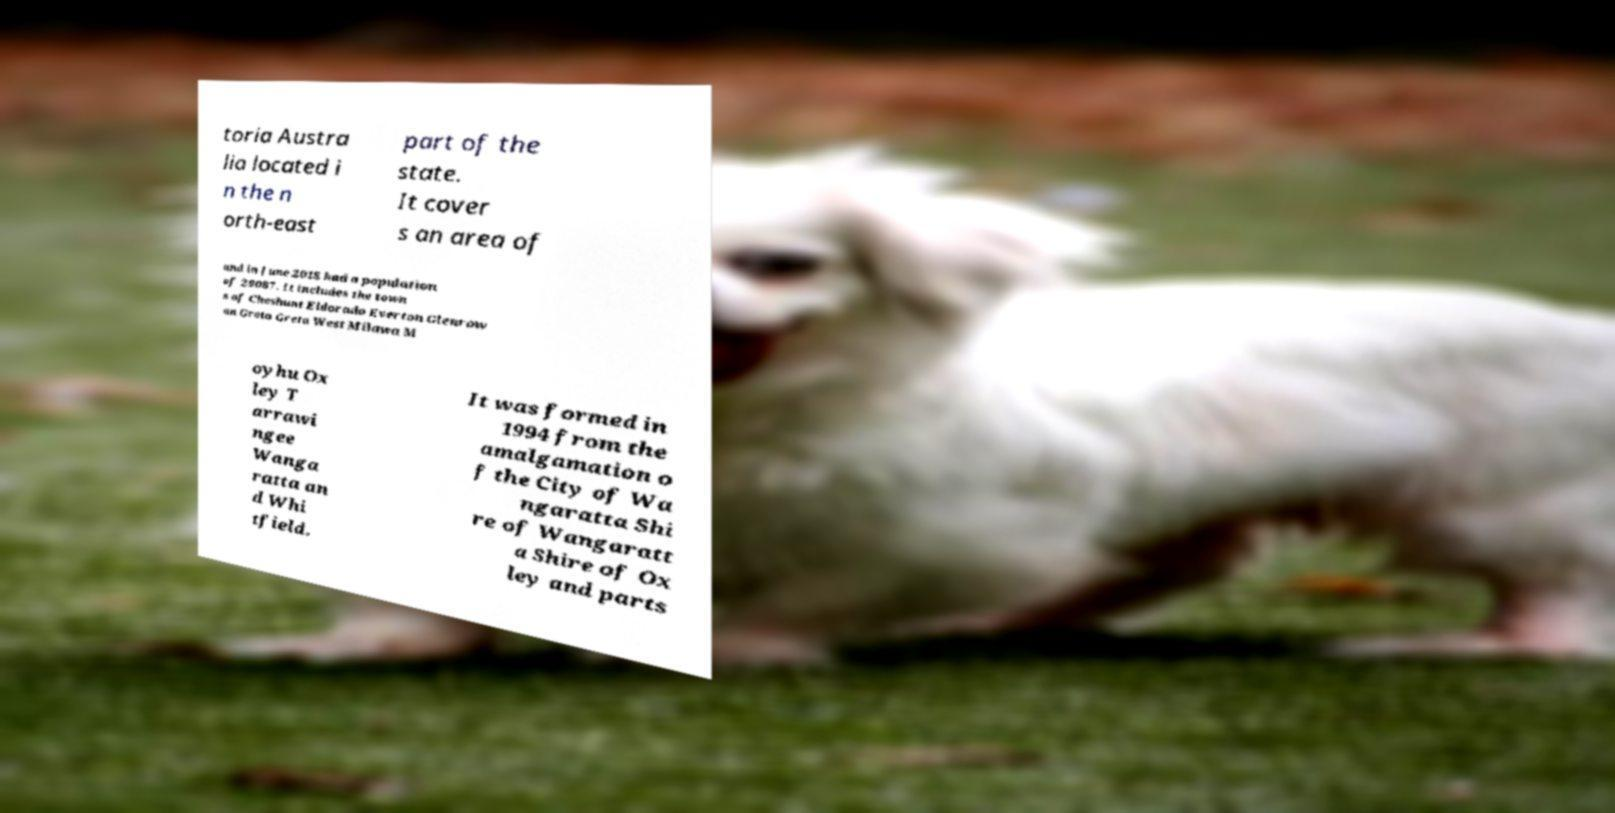What messages or text are displayed in this image? I need them in a readable, typed format. toria Austra lia located i n the n orth-east part of the state. It cover s an area of and in June 2018 had a population of 29087. It includes the town s of Cheshunt Eldorado Everton Glenrow an Greta Greta West Milawa M oyhu Ox ley T arrawi ngee Wanga ratta an d Whi tfield. It was formed in 1994 from the amalgamation o f the City of Wa ngaratta Shi re of Wangaratt a Shire of Ox ley and parts 